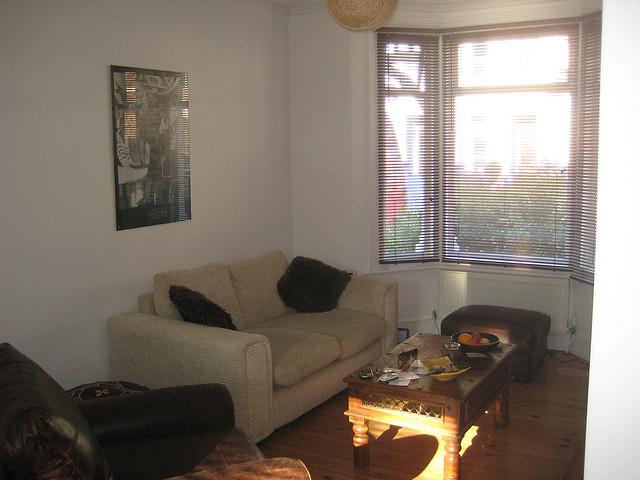Is it nighttime outside?
Keep it brief. No. What is the floor made of?
Write a very short answer. Wood. Is the table clean?
Be succinct. No. 